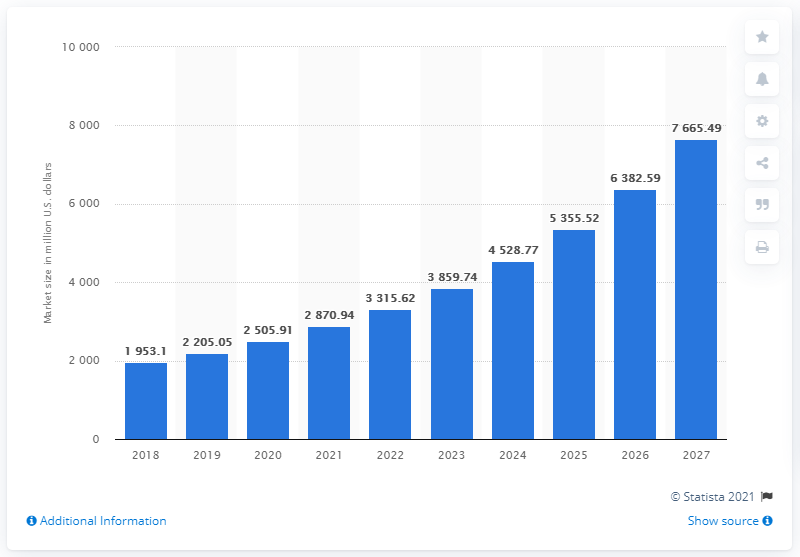Highlight a few significant elements in this photo. By 2027, the global clear aligners market is projected to reach 7.7 billion dollars. 